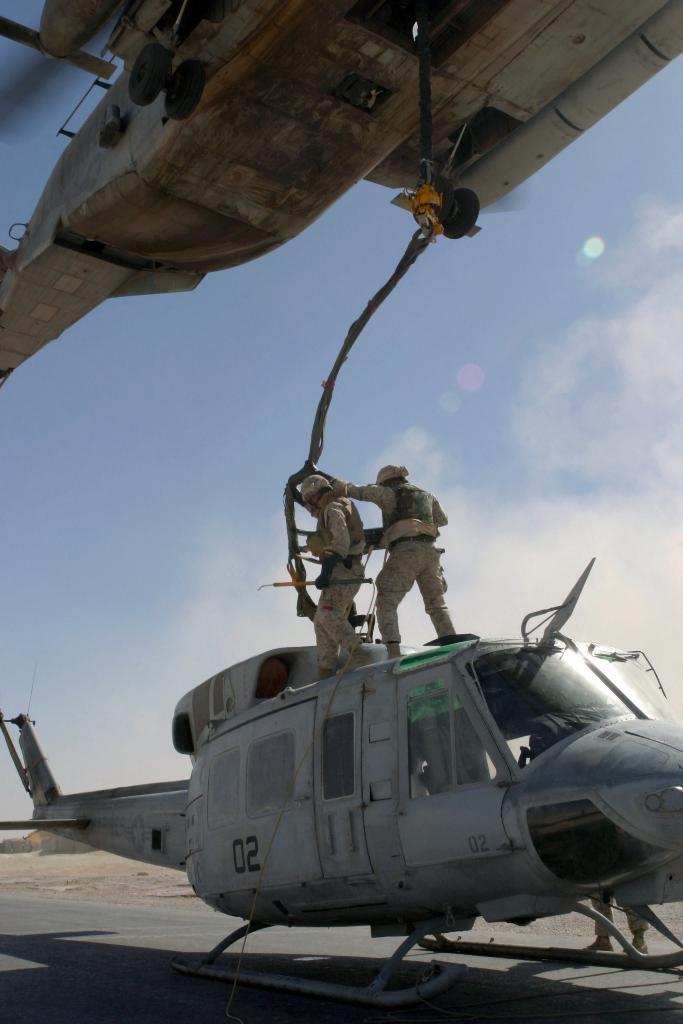<image>
Provide a brief description of the given image. Soldiers are connecting a cable from a hovering helicopter to a grounded helicopter marked 02. 